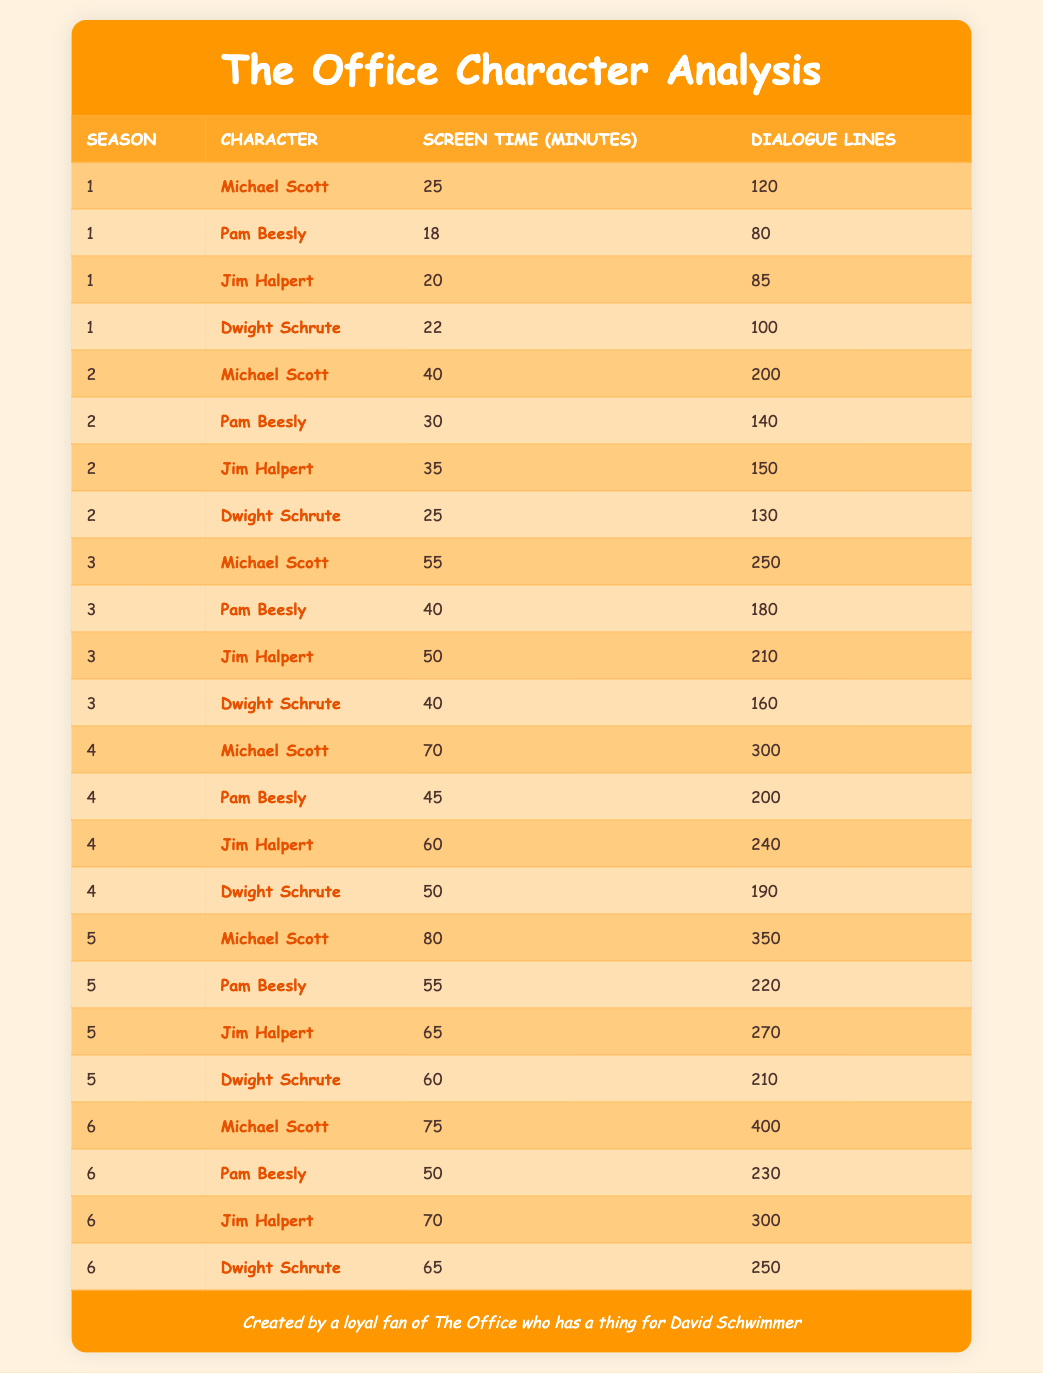What was Michael Scott's total dialogue lines across all seasons? To find Michael Scott's total dialogue lines, we need to sum the dialogue lines from all seasons where he appears: 120 (Season 1) + 200 (Season 2) + 250 (Season 3) + 300 (Season 4) + 350 (Season 5) + 400 (Season 6) = 1620
Answer: 1620 Which character had the most screen time in Season 5? In Season 5, the screen times are as follows: Michael Scott – 80 minutes, Pam Beesly – 55 minutes, Jim Halpert – 65 minutes, and Dwight Schrute – 60 minutes. Michael Scott has the highest at 80 minutes
Answer: 80 What is the average screen time for Jim Halpert across all six seasons? Jim Halpert's screen times are: 20 (Season 1), 35 (Season 2), 50 (Season 3), 60 (Season 4), 65 (Season 5), and 70 (Season 6). Adding these gives 20 + 35 + 50 + 60 + 65 + 70 = 300 minutes. Dividing by the number of seasons (6) gives us an average of 300 / 6 = 50
Answer: 50 Did Pam Beesly have more dialogue lines than Dwight Schrute in Season 3? In Season 3, Pam Beesly has 180 dialogue lines and Dwight Schrute has 160. Since 180 is greater than 160, the answer is yes
Answer: Yes What was the increase in Michael Scott's screen time from Season 1 to Season 4? Michael Scott's screen time in Season 1 is 25 minutes and in Season 4 it is 70 minutes. The increase is 70 - 25 = 45 minutes
Answer: 45 